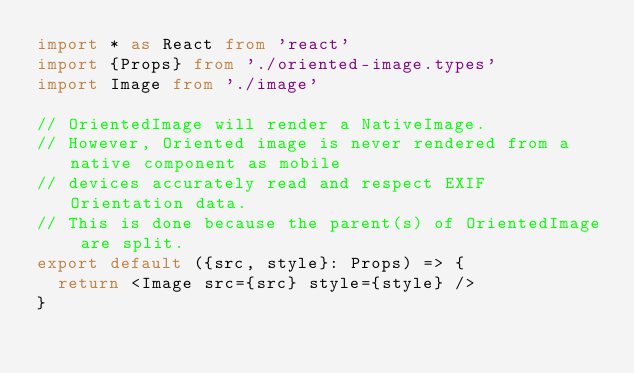Convert code to text. <code><loc_0><loc_0><loc_500><loc_500><_TypeScript_>import * as React from 'react'
import {Props} from './oriented-image.types'
import Image from './image'

// OrientedImage will render a NativeImage.
// However, Oriented image is never rendered from a native component as mobile
// devices accurately read and respect EXIF Orientation data.
// This is done because the parent(s) of OrientedImage are split.
export default ({src, style}: Props) => {
  return <Image src={src} style={style} />
}
</code> 